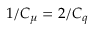<formula> <loc_0><loc_0><loc_500><loc_500>1 / C _ { \mu } = 2 / C _ { q }</formula> 